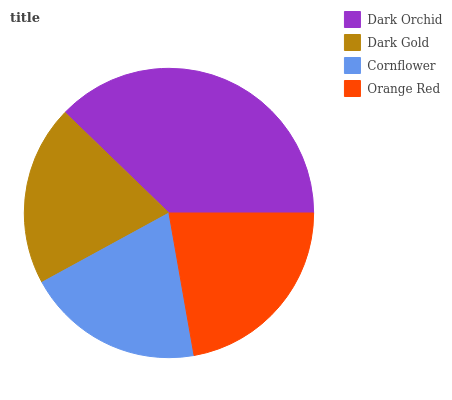Is Cornflower the minimum?
Answer yes or no. Yes. Is Dark Orchid the maximum?
Answer yes or no. Yes. Is Dark Gold the minimum?
Answer yes or no. No. Is Dark Gold the maximum?
Answer yes or no. No. Is Dark Orchid greater than Dark Gold?
Answer yes or no. Yes. Is Dark Gold less than Dark Orchid?
Answer yes or no. Yes. Is Dark Gold greater than Dark Orchid?
Answer yes or no. No. Is Dark Orchid less than Dark Gold?
Answer yes or no. No. Is Orange Red the high median?
Answer yes or no. Yes. Is Dark Gold the low median?
Answer yes or no. Yes. Is Dark Orchid the high median?
Answer yes or no. No. Is Dark Orchid the low median?
Answer yes or no. No. 